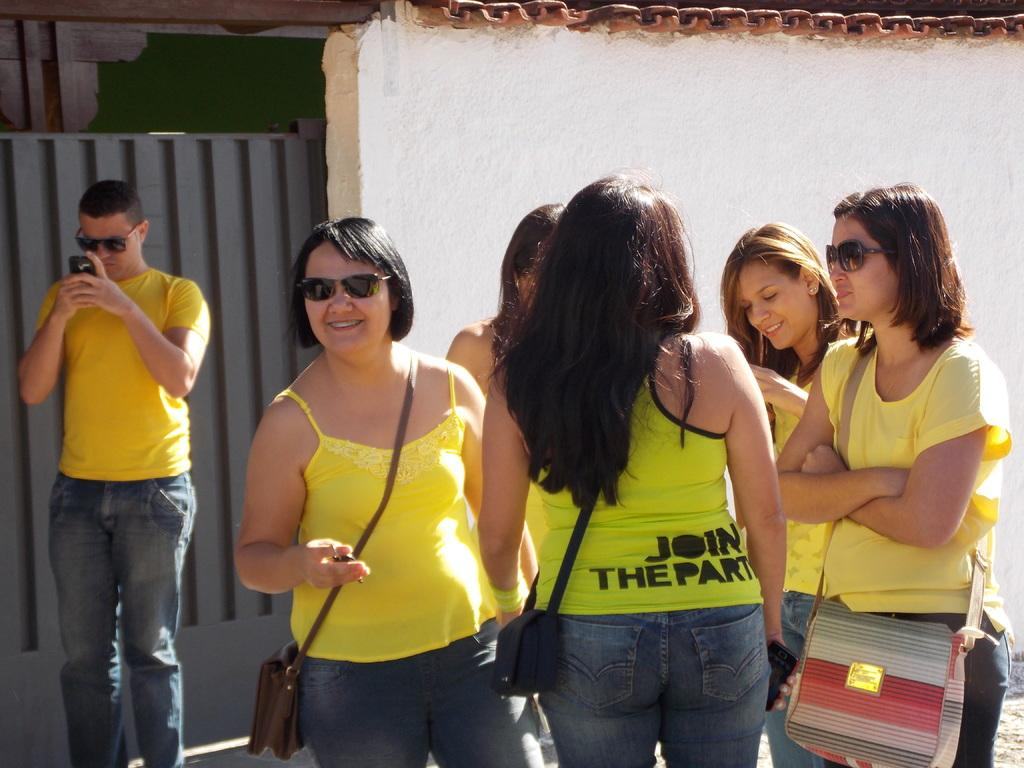How many people are in the image? There is a group of people standing in the image, but the exact number cannot be determined from the provided facts. What is the person holding in the image? There is a person holding an object in the image, but the specific object cannot be identified from the provided facts. What can be seen in the background of the image? There is a wall and a gate in the background of the image. How much money is being exchanged between the people in the image? There is no mention of money or any exchange of currency in the provided facts, so it cannot be determined from the image. 